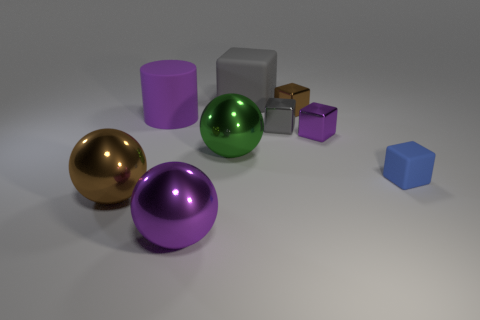There is a ball that is the same color as the cylinder; what size is it?
Make the answer very short. Large. How many objects are either large brown things or shiny spheres that are behind the blue cube?
Give a very brief answer. 2. Are there any blue objects made of the same material as the big gray thing?
Keep it short and to the point. Yes. How many objects are both right of the small purple metallic thing and on the left side of the large purple cylinder?
Keep it short and to the point. 0. What is the brown thing right of the big cylinder made of?
Offer a very short reply. Metal. There is a purple sphere that is made of the same material as the large green sphere; what is its size?
Your answer should be very brief. Large. There is a blue block; are there any large objects in front of it?
Keep it short and to the point. Yes. There is a gray metallic object that is the same shape as the blue object; what size is it?
Ensure brevity in your answer.  Small. There is a large block; is its color the same as the small metal thing that is left of the brown block?
Your response must be concise. Yes. Are there fewer large gray rubber objects than big blue balls?
Ensure brevity in your answer.  No. 